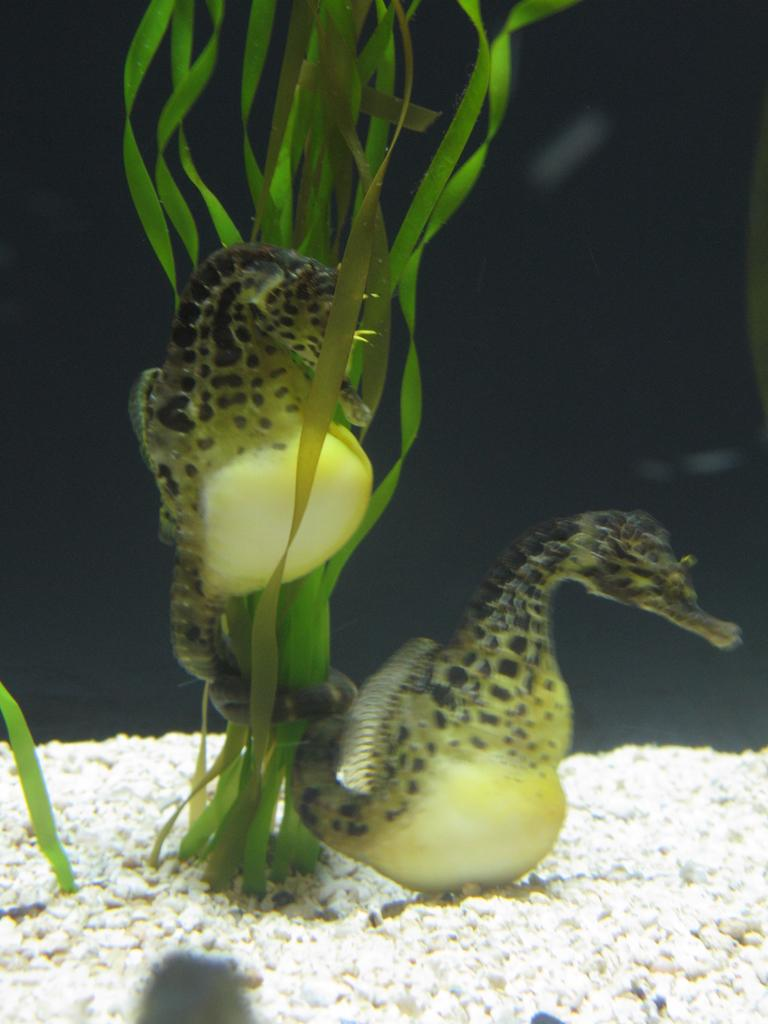What type of animals can be seen in the image? There are seahorses in the water. What else can be seen in the image besides the seahorses? There are plants and stones visible in the image. What type of credit can be seen being offered in the image? There is no credit or financial transaction depicted in the image; it features seahorses, plants, and stones in the water. 